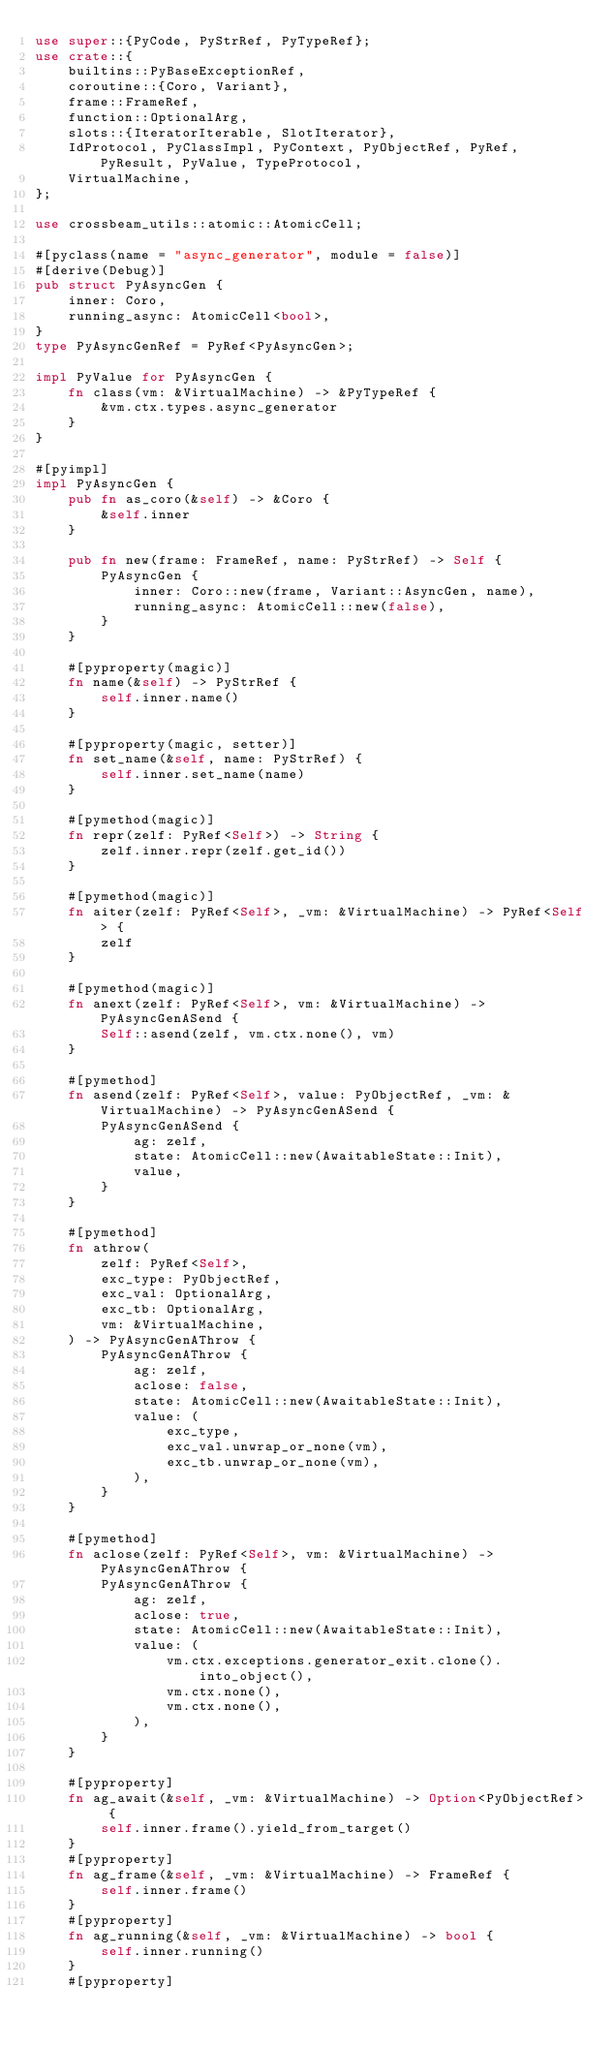<code> <loc_0><loc_0><loc_500><loc_500><_Rust_>use super::{PyCode, PyStrRef, PyTypeRef};
use crate::{
    builtins::PyBaseExceptionRef,
    coroutine::{Coro, Variant},
    frame::FrameRef,
    function::OptionalArg,
    slots::{IteratorIterable, SlotIterator},
    IdProtocol, PyClassImpl, PyContext, PyObjectRef, PyRef, PyResult, PyValue, TypeProtocol,
    VirtualMachine,
};

use crossbeam_utils::atomic::AtomicCell;

#[pyclass(name = "async_generator", module = false)]
#[derive(Debug)]
pub struct PyAsyncGen {
    inner: Coro,
    running_async: AtomicCell<bool>,
}
type PyAsyncGenRef = PyRef<PyAsyncGen>;

impl PyValue for PyAsyncGen {
    fn class(vm: &VirtualMachine) -> &PyTypeRef {
        &vm.ctx.types.async_generator
    }
}

#[pyimpl]
impl PyAsyncGen {
    pub fn as_coro(&self) -> &Coro {
        &self.inner
    }

    pub fn new(frame: FrameRef, name: PyStrRef) -> Self {
        PyAsyncGen {
            inner: Coro::new(frame, Variant::AsyncGen, name),
            running_async: AtomicCell::new(false),
        }
    }

    #[pyproperty(magic)]
    fn name(&self) -> PyStrRef {
        self.inner.name()
    }

    #[pyproperty(magic, setter)]
    fn set_name(&self, name: PyStrRef) {
        self.inner.set_name(name)
    }

    #[pymethod(magic)]
    fn repr(zelf: PyRef<Self>) -> String {
        zelf.inner.repr(zelf.get_id())
    }

    #[pymethod(magic)]
    fn aiter(zelf: PyRef<Self>, _vm: &VirtualMachine) -> PyRef<Self> {
        zelf
    }

    #[pymethod(magic)]
    fn anext(zelf: PyRef<Self>, vm: &VirtualMachine) -> PyAsyncGenASend {
        Self::asend(zelf, vm.ctx.none(), vm)
    }

    #[pymethod]
    fn asend(zelf: PyRef<Self>, value: PyObjectRef, _vm: &VirtualMachine) -> PyAsyncGenASend {
        PyAsyncGenASend {
            ag: zelf,
            state: AtomicCell::new(AwaitableState::Init),
            value,
        }
    }

    #[pymethod]
    fn athrow(
        zelf: PyRef<Self>,
        exc_type: PyObjectRef,
        exc_val: OptionalArg,
        exc_tb: OptionalArg,
        vm: &VirtualMachine,
    ) -> PyAsyncGenAThrow {
        PyAsyncGenAThrow {
            ag: zelf,
            aclose: false,
            state: AtomicCell::new(AwaitableState::Init),
            value: (
                exc_type,
                exc_val.unwrap_or_none(vm),
                exc_tb.unwrap_or_none(vm),
            ),
        }
    }

    #[pymethod]
    fn aclose(zelf: PyRef<Self>, vm: &VirtualMachine) -> PyAsyncGenAThrow {
        PyAsyncGenAThrow {
            ag: zelf,
            aclose: true,
            state: AtomicCell::new(AwaitableState::Init),
            value: (
                vm.ctx.exceptions.generator_exit.clone().into_object(),
                vm.ctx.none(),
                vm.ctx.none(),
            ),
        }
    }

    #[pyproperty]
    fn ag_await(&self, _vm: &VirtualMachine) -> Option<PyObjectRef> {
        self.inner.frame().yield_from_target()
    }
    #[pyproperty]
    fn ag_frame(&self, _vm: &VirtualMachine) -> FrameRef {
        self.inner.frame()
    }
    #[pyproperty]
    fn ag_running(&self, _vm: &VirtualMachine) -> bool {
        self.inner.running()
    }
    #[pyproperty]</code> 